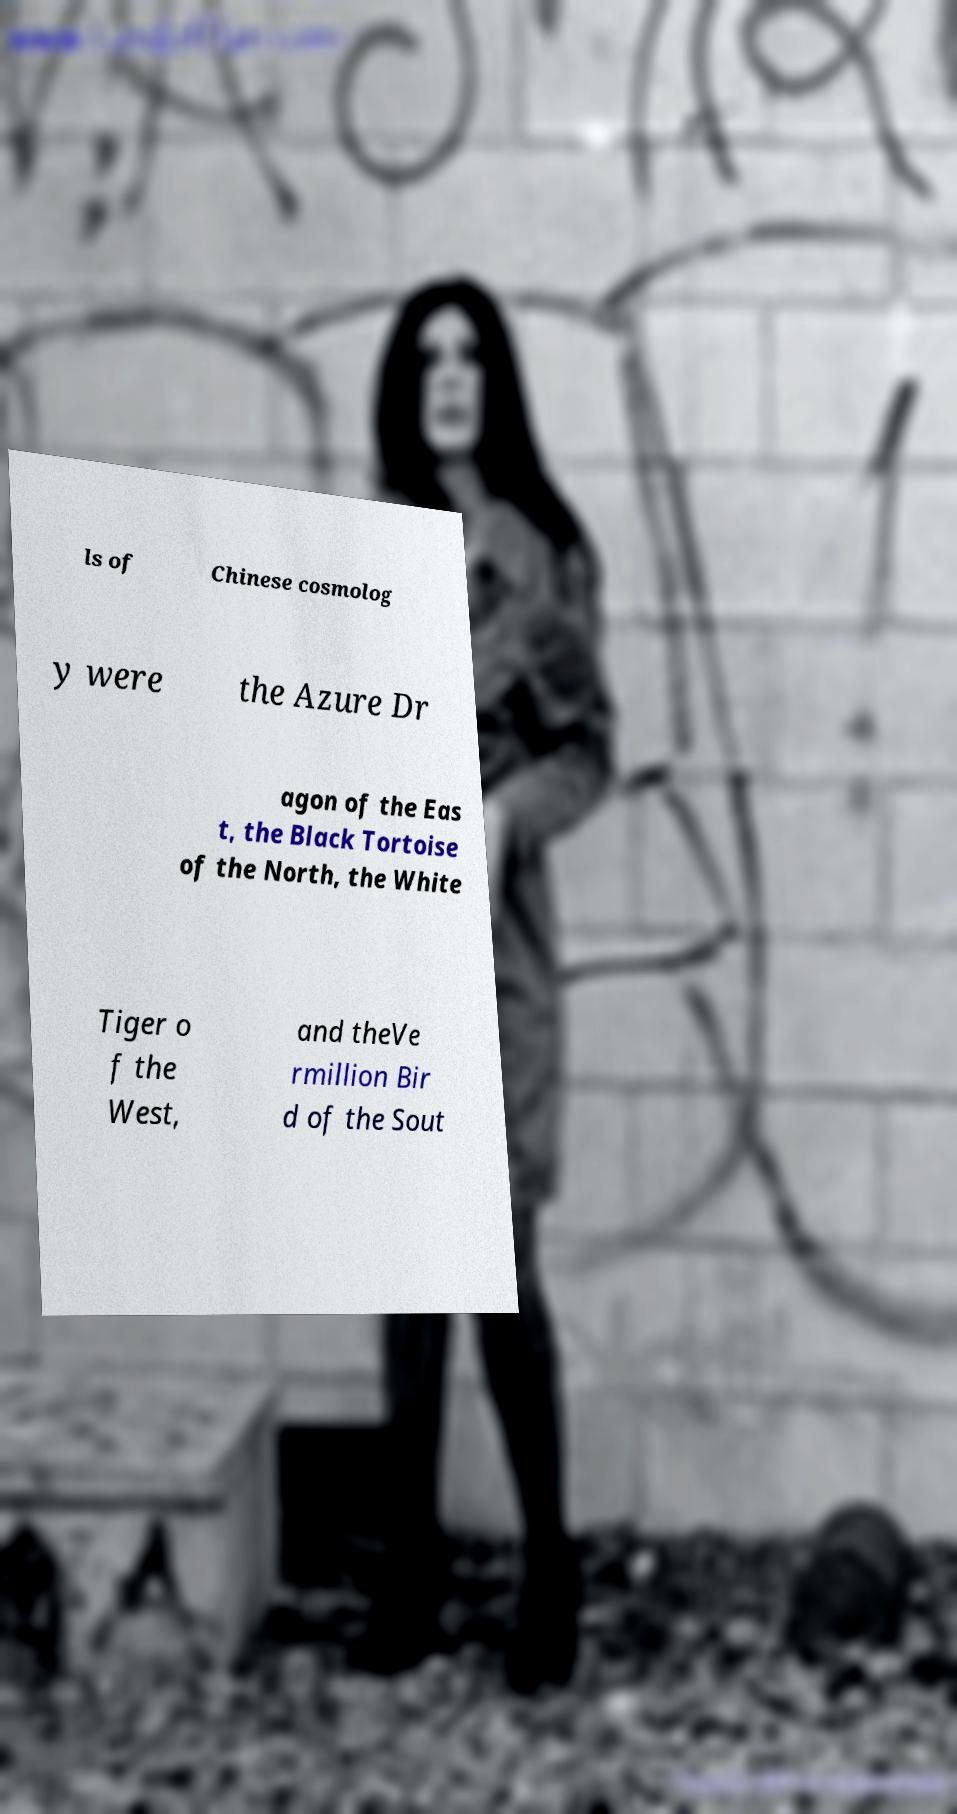What messages or text are displayed in this image? I need them in a readable, typed format. ls of Chinese cosmolog y were the Azure Dr agon of the Eas t, the Black Tortoise of the North, the White Tiger o f the West, and theVe rmillion Bir d of the Sout 